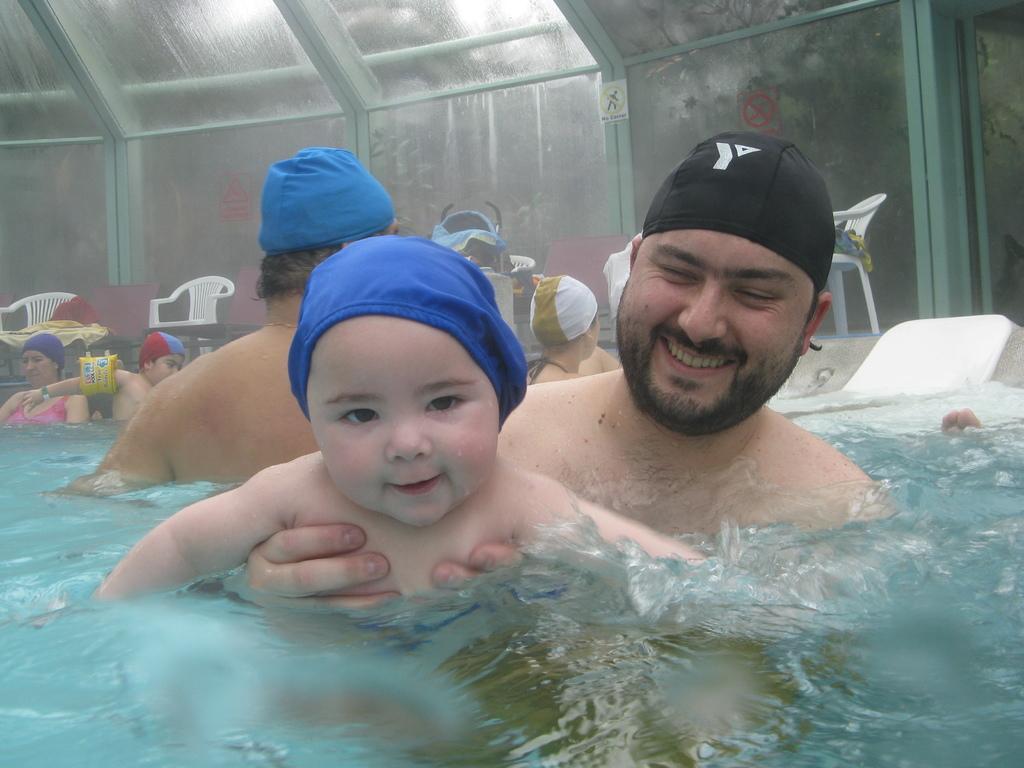Please provide a concise description of this image. In the image we can see there are people swimming in the water, they are wearing head caps and behind there are chairs kept on the ground. 